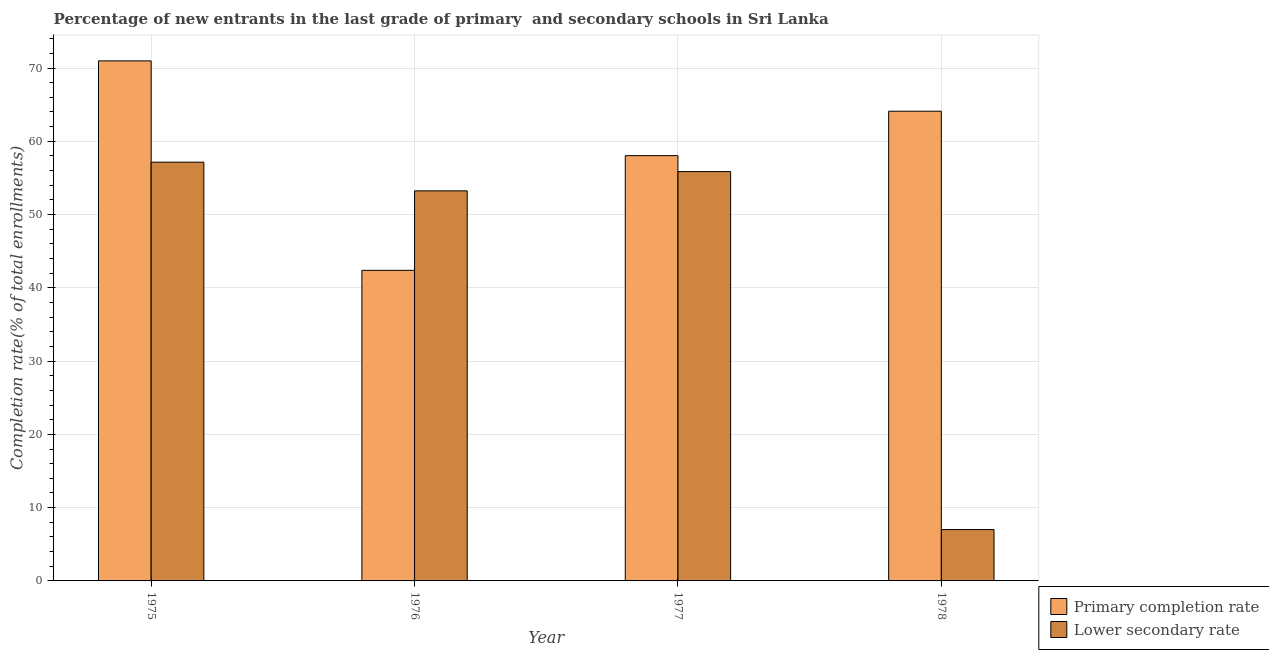How many different coloured bars are there?
Your answer should be very brief. 2. How many groups of bars are there?
Provide a succinct answer. 4. Are the number of bars per tick equal to the number of legend labels?
Make the answer very short. Yes. Are the number of bars on each tick of the X-axis equal?
Give a very brief answer. Yes. How many bars are there on the 1st tick from the left?
Offer a terse response. 2. What is the label of the 4th group of bars from the left?
Offer a very short reply. 1978. What is the completion rate in primary schools in 1976?
Offer a terse response. 42.39. Across all years, what is the maximum completion rate in secondary schools?
Provide a succinct answer. 57.15. Across all years, what is the minimum completion rate in secondary schools?
Offer a very short reply. 7.01. In which year was the completion rate in primary schools maximum?
Keep it short and to the point. 1975. In which year was the completion rate in primary schools minimum?
Offer a terse response. 1976. What is the total completion rate in primary schools in the graph?
Keep it short and to the point. 235.5. What is the difference between the completion rate in primary schools in 1976 and that in 1978?
Provide a short and direct response. -21.72. What is the difference between the completion rate in primary schools in 1975 and the completion rate in secondary schools in 1976?
Keep it short and to the point. 28.59. What is the average completion rate in secondary schools per year?
Keep it short and to the point. 43.31. In the year 1975, what is the difference between the completion rate in secondary schools and completion rate in primary schools?
Ensure brevity in your answer.  0. What is the ratio of the completion rate in primary schools in 1975 to that in 1976?
Keep it short and to the point. 1.67. Is the completion rate in primary schools in 1975 less than that in 1976?
Your answer should be compact. No. What is the difference between the highest and the second highest completion rate in secondary schools?
Your answer should be compact. 1.29. What is the difference between the highest and the lowest completion rate in secondary schools?
Offer a terse response. 50.14. In how many years, is the completion rate in secondary schools greater than the average completion rate in secondary schools taken over all years?
Keep it short and to the point. 3. Is the sum of the completion rate in secondary schools in 1975 and 1976 greater than the maximum completion rate in primary schools across all years?
Keep it short and to the point. Yes. What does the 1st bar from the left in 1978 represents?
Provide a short and direct response. Primary completion rate. What does the 2nd bar from the right in 1978 represents?
Your answer should be very brief. Primary completion rate. How many bars are there?
Offer a very short reply. 8. What is the difference between two consecutive major ticks on the Y-axis?
Provide a short and direct response. 10. Are the values on the major ticks of Y-axis written in scientific E-notation?
Keep it short and to the point. No. Does the graph contain grids?
Your answer should be very brief. Yes. How many legend labels are there?
Provide a short and direct response. 2. What is the title of the graph?
Ensure brevity in your answer.  Percentage of new entrants in the last grade of primary  and secondary schools in Sri Lanka. What is the label or title of the Y-axis?
Offer a terse response. Completion rate(% of total enrollments). What is the Completion rate(% of total enrollments) in Primary completion rate in 1975?
Keep it short and to the point. 70.97. What is the Completion rate(% of total enrollments) in Lower secondary rate in 1975?
Keep it short and to the point. 57.15. What is the Completion rate(% of total enrollments) of Primary completion rate in 1976?
Provide a succinct answer. 42.39. What is the Completion rate(% of total enrollments) of Lower secondary rate in 1976?
Offer a terse response. 53.24. What is the Completion rate(% of total enrollments) in Primary completion rate in 1977?
Give a very brief answer. 58.04. What is the Completion rate(% of total enrollments) in Lower secondary rate in 1977?
Give a very brief answer. 55.86. What is the Completion rate(% of total enrollments) in Primary completion rate in 1978?
Keep it short and to the point. 64.1. What is the Completion rate(% of total enrollments) of Lower secondary rate in 1978?
Provide a succinct answer. 7.01. Across all years, what is the maximum Completion rate(% of total enrollments) of Primary completion rate?
Offer a very short reply. 70.97. Across all years, what is the maximum Completion rate(% of total enrollments) in Lower secondary rate?
Offer a very short reply. 57.15. Across all years, what is the minimum Completion rate(% of total enrollments) of Primary completion rate?
Make the answer very short. 42.39. Across all years, what is the minimum Completion rate(% of total enrollments) in Lower secondary rate?
Offer a terse response. 7.01. What is the total Completion rate(% of total enrollments) in Primary completion rate in the graph?
Offer a terse response. 235.5. What is the total Completion rate(% of total enrollments) in Lower secondary rate in the graph?
Offer a very short reply. 173.26. What is the difference between the Completion rate(% of total enrollments) in Primary completion rate in 1975 and that in 1976?
Offer a terse response. 28.59. What is the difference between the Completion rate(% of total enrollments) of Lower secondary rate in 1975 and that in 1976?
Provide a short and direct response. 3.91. What is the difference between the Completion rate(% of total enrollments) of Primary completion rate in 1975 and that in 1977?
Offer a terse response. 12.93. What is the difference between the Completion rate(% of total enrollments) of Lower secondary rate in 1975 and that in 1977?
Offer a very short reply. 1.29. What is the difference between the Completion rate(% of total enrollments) of Primary completion rate in 1975 and that in 1978?
Provide a short and direct response. 6.87. What is the difference between the Completion rate(% of total enrollments) in Lower secondary rate in 1975 and that in 1978?
Keep it short and to the point. 50.14. What is the difference between the Completion rate(% of total enrollments) in Primary completion rate in 1976 and that in 1977?
Your answer should be very brief. -15.65. What is the difference between the Completion rate(% of total enrollments) of Lower secondary rate in 1976 and that in 1977?
Provide a short and direct response. -2.62. What is the difference between the Completion rate(% of total enrollments) in Primary completion rate in 1976 and that in 1978?
Provide a short and direct response. -21.72. What is the difference between the Completion rate(% of total enrollments) in Lower secondary rate in 1976 and that in 1978?
Provide a succinct answer. 46.23. What is the difference between the Completion rate(% of total enrollments) in Primary completion rate in 1977 and that in 1978?
Ensure brevity in your answer.  -6.06. What is the difference between the Completion rate(% of total enrollments) of Lower secondary rate in 1977 and that in 1978?
Your answer should be compact. 48.85. What is the difference between the Completion rate(% of total enrollments) of Primary completion rate in 1975 and the Completion rate(% of total enrollments) of Lower secondary rate in 1976?
Your response must be concise. 17.74. What is the difference between the Completion rate(% of total enrollments) in Primary completion rate in 1975 and the Completion rate(% of total enrollments) in Lower secondary rate in 1977?
Give a very brief answer. 15.11. What is the difference between the Completion rate(% of total enrollments) in Primary completion rate in 1975 and the Completion rate(% of total enrollments) in Lower secondary rate in 1978?
Make the answer very short. 63.97. What is the difference between the Completion rate(% of total enrollments) in Primary completion rate in 1976 and the Completion rate(% of total enrollments) in Lower secondary rate in 1977?
Offer a terse response. -13.47. What is the difference between the Completion rate(% of total enrollments) of Primary completion rate in 1976 and the Completion rate(% of total enrollments) of Lower secondary rate in 1978?
Make the answer very short. 35.38. What is the difference between the Completion rate(% of total enrollments) of Primary completion rate in 1977 and the Completion rate(% of total enrollments) of Lower secondary rate in 1978?
Offer a very short reply. 51.03. What is the average Completion rate(% of total enrollments) of Primary completion rate per year?
Provide a short and direct response. 58.88. What is the average Completion rate(% of total enrollments) in Lower secondary rate per year?
Keep it short and to the point. 43.31. In the year 1975, what is the difference between the Completion rate(% of total enrollments) of Primary completion rate and Completion rate(% of total enrollments) of Lower secondary rate?
Offer a terse response. 13.82. In the year 1976, what is the difference between the Completion rate(% of total enrollments) in Primary completion rate and Completion rate(% of total enrollments) in Lower secondary rate?
Keep it short and to the point. -10.85. In the year 1977, what is the difference between the Completion rate(% of total enrollments) of Primary completion rate and Completion rate(% of total enrollments) of Lower secondary rate?
Keep it short and to the point. 2.18. In the year 1978, what is the difference between the Completion rate(% of total enrollments) in Primary completion rate and Completion rate(% of total enrollments) in Lower secondary rate?
Your answer should be compact. 57.1. What is the ratio of the Completion rate(% of total enrollments) in Primary completion rate in 1975 to that in 1976?
Your answer should be compact. 1.67. What is the ratio of the Completion rate(% of total enrollments) of Lower secondary rate in 1975 to that in 1976?
Offer a terse response. 1.07. What is the ratio of the Completion rate(% of total enrollments) of Primary completion rate in 1975 to that in 1977?
Provide a succinct answer. 1.22. What is the ratio of the Completion rate(% of total enrollments) of Lower secondary rate in 1975 to that in 1977?
Offer a terse response. 1.02. What is the ratio of the Completion rate(% of total enrollments) in Primary completion rate in 1975 to that in 1978?
Give a very brief answer. 1.11. What is the ratio of the Completion rate(% of total enrollments) in Lower secondary rate in 1975 to that in 1978?
Your answer should be very brief. 8.16. What is the ratio of the Completion rate(% of total enrollments) of Primary completion rate in 1976 to that in 1977?
Offer a terse response. 0.73. What is the ratio of the Completion rate(% of total enrollments) of Lower secondary rate in 1976 to that in 1977?
Your answer should be compact. 0.95. What is the ratio of the Completion rate(% of total enrollments) in Primary completion rate in 1976 to that in 1978?
Offer a terse response. 0.66. What is the ratio of the Completion rate(% of total enrollments) in Lower secondary rate in 1976 to that in 1978?
Give a very brief answer. 7.6. What is the ratio of the Completion rate(% of total enrollments) of Primary completion rate in 1977 to that in 1978?
Ensure brevity in your answer.  0.91. What is the ratio of the Completion rate(% of total enrollments) in Lower secondary rate in 1977 to that in 1978?
Your answer should be very brief. 7.97. What is the difference between the highest and the second highest Completion rate(% of total enrollments) in Primary completion rate?
Provide a succinct answer. 6.87. What is the difference between the highest and the second highest Completion rate(% of total enrollments) of Lower secondary rate?
Offer a very short reply. 1.29. What is the difference between the highest and the lowest Completion rate(% of total enrollments) of Primary completion rate?
Provide a short and direct response. 28.59. What is the difference between the highest and the lowest Completion rate(% of total enrollments) of Lower secondary rate?
Make the answer very short. 50.14. 